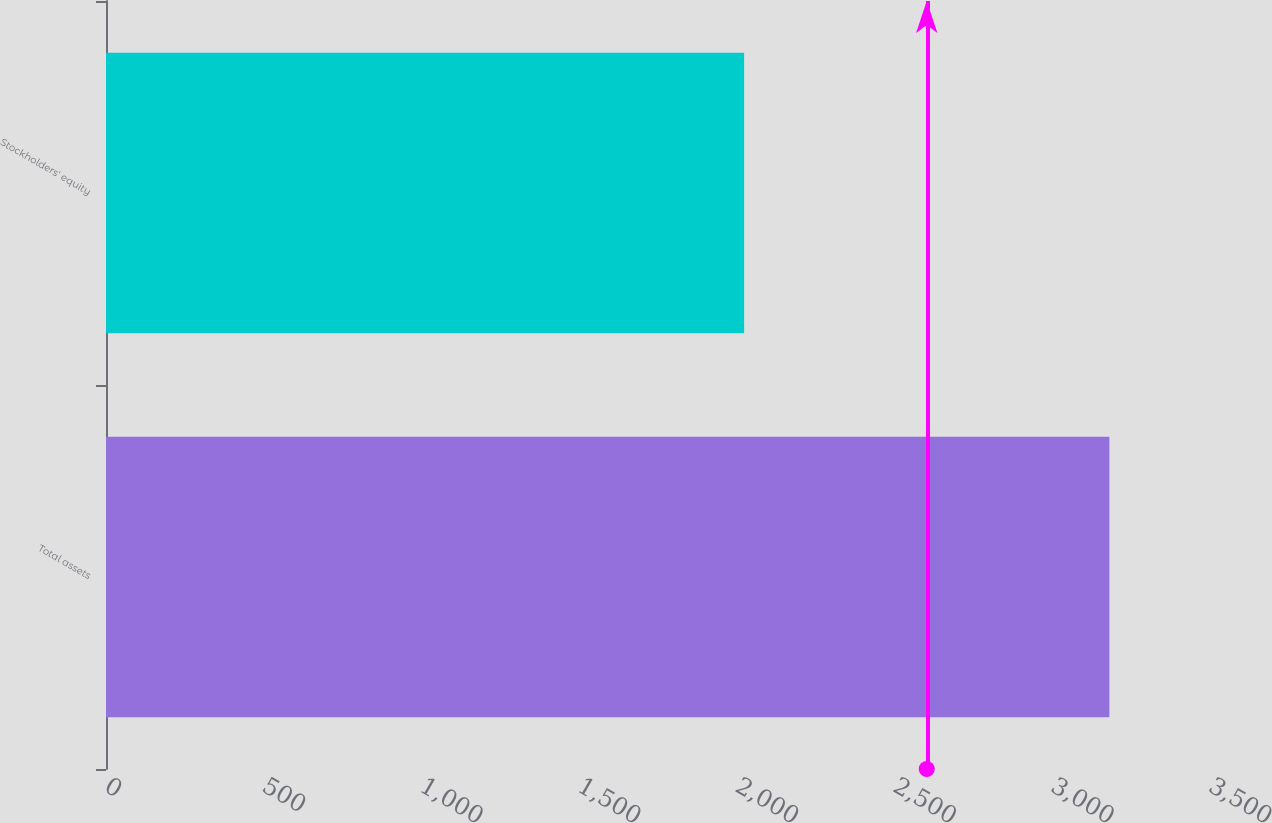<chart> <loc_0><loc_0><loc_500><loc_500><bar_chart><fcel>Total assets<fcel>Stockholders' equity<nl><fcel>3181<fcel>2023<nl></chart> 